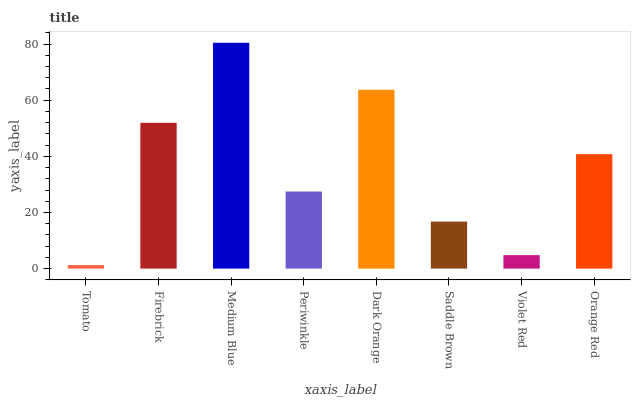Is Tomato the minimum?
Answer yes or no. Yes. Is Medium Blue the maximum?
Answer yes or no. Yes. Is Firebrick the minimum?
Answer yes or no. No. Is Firebrick the maximum?
Answer yes or no. No. Is Firebrick greater than Tomato?
Answer yes or no. Yes. Is Tomato less than Firebrick?
Answer yes or no. Yes. Is Tomato greater than Firebrick?
Answer yes or no. No. Is Firebrick less than Tomato?
Answer yes or no. No. Is Orange Red the high median?
Answer yes or no. Yes. Is Periwinkle the low median?
Answer yes or no. Yes. Is Firebrick the high median?
Answer yes or no. No. Is Saddle Brown the low median?
Answer yes or no. No. 